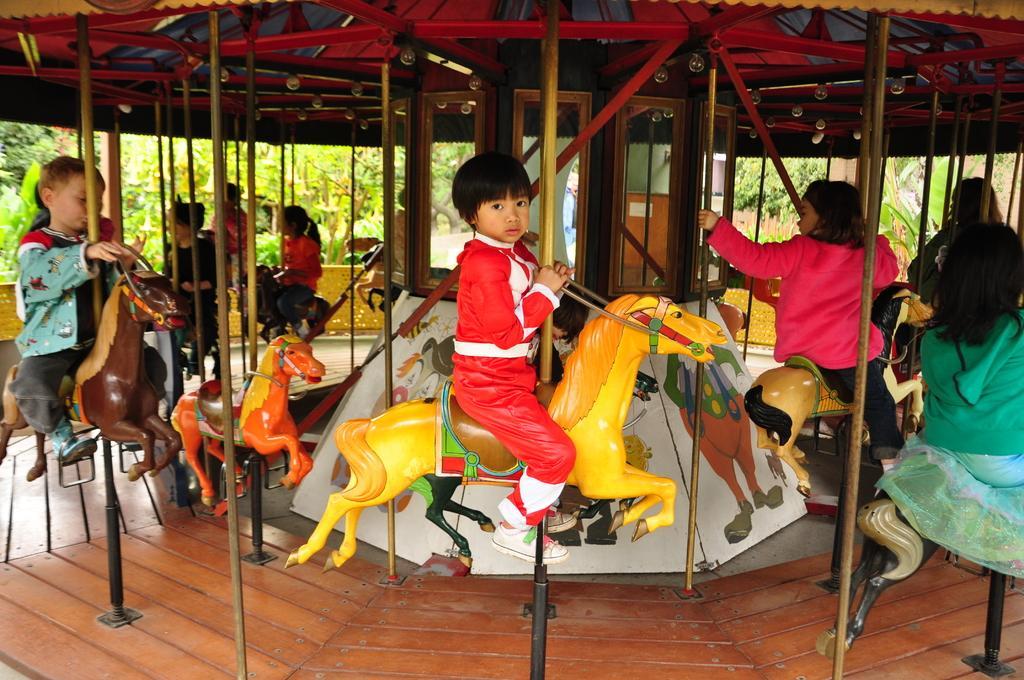Please provide a concise description of this image. In this picture I can see there is a carousel and there are some kids sitting on the horses in the carousel and in the backdrop I can see there are trees and a wall. 